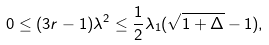Convert formula to latex. <formula><loc_0><loc_0><loc_500><loc_500>0 \leq ( 3 r - 1 ) \lambda ^ { 2 } \leq { \frac { 1 } { 2 } } \lambda _ { 1 } ( \sqrt { 1 + \Delta } - 1 ) ,</formula> 